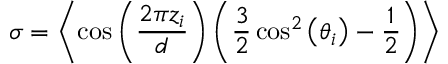<formula> <loc_0><loc_0><loc_500><loc_500>\sigma = \left \langle \cos \left ( { \frac { 2 \pi z _ { i } } { d } } \right ) \left ( { \frac { 3 } { 2 } } \cos ^ { 2 } \left ( \theta _ { i } \right ) - { \frac { 1 } { 2 } } \right ) \right \rangle</formula> 